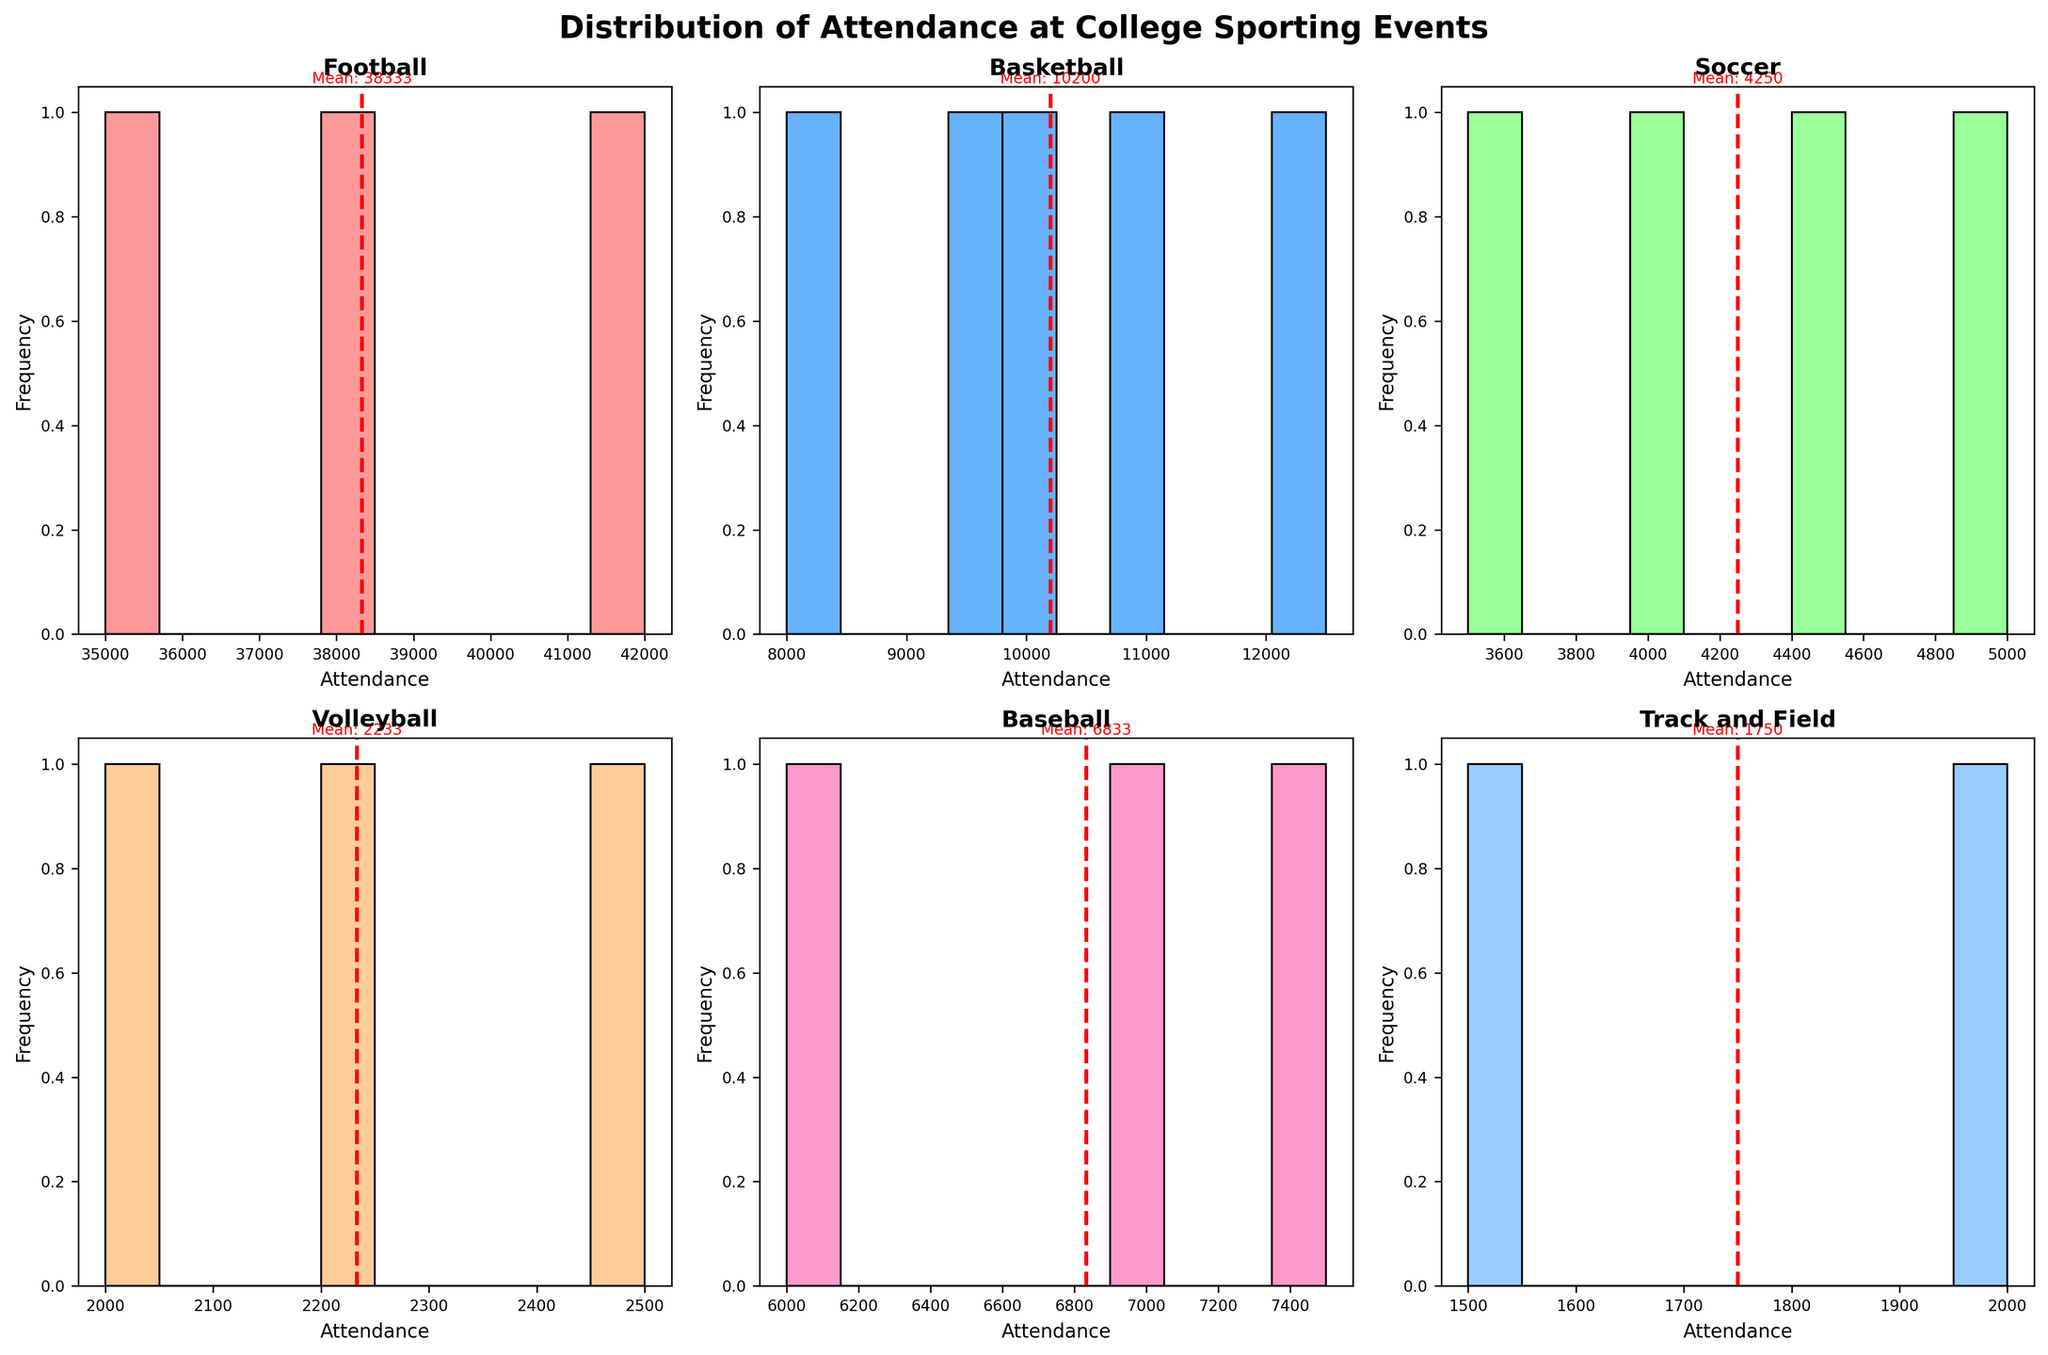Which sport has the highest attendance mean according to the histograms? Look at each subplot and observe the red dashed lines that represent the mean attendance. Football's red line is positioned at the highest attendance value in comparison to other sports.
Answer: Football What is the title of the figure? The large text at the top of the figure provides the title.
Answer: Distribution of Attendance at College Sporting Events Which sport has the lowest attendance in any month shown? Examine the x-axis ranges and the histograms for the lowest attendance values. Track and Field in April shows an attendance count as low as 1500.
Answer: Track and Field What is the average attendance for Volleyball? Based on the red dashed line in the Volleyball subplot, the mean attendance can be directly read off the plot. The line indicates a mean around 2233.33.
Answer: 2233 Compare the mean attendance for Soccer and Baseball. Which one is higher? Look at the red dashed lines in the Soccer and Baseball subplots. The dashed line for Baseball is higher than that for Soccer.
Answer: Baseball Which sport shows increasing attendance from September to October? Observe the sequential increase in the heights of the bars from September to October in Soccer and Football histograms.
Answer: Football, Soccer Does the Basketball attendance distribution show a steady increase over the months? Look at the histogram bars for Basketball and compare attendance from November to March. The heights of the bars mostly increase, indicating a steady rise.
Answer: Yes Among the sports listed, which month has the highest attendance on average? By compiling the histograms, October shows high attendance for Football and increasing trends for other sports.
Answer: October What are the two months with the highest attendance for Football? Check the histogram for Football and find the months with the highest bar heights. They are October and September.
Answer: October, September 